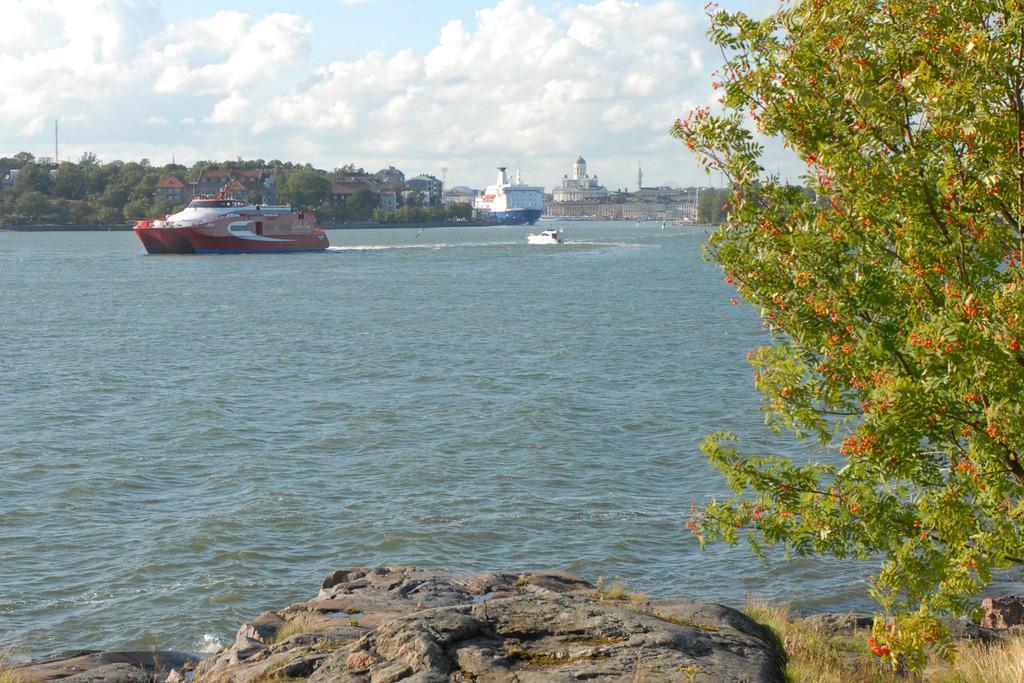Could you give a brief overview of what you see in this image? In the center of the image we can see the boats are present on the water. In the background of the image we can see the buildings, trees, poles. At the bottom of the image we can see the rocks, grass and a tree with flowers. At the top of the image we can see the clouds are present in the sky. 